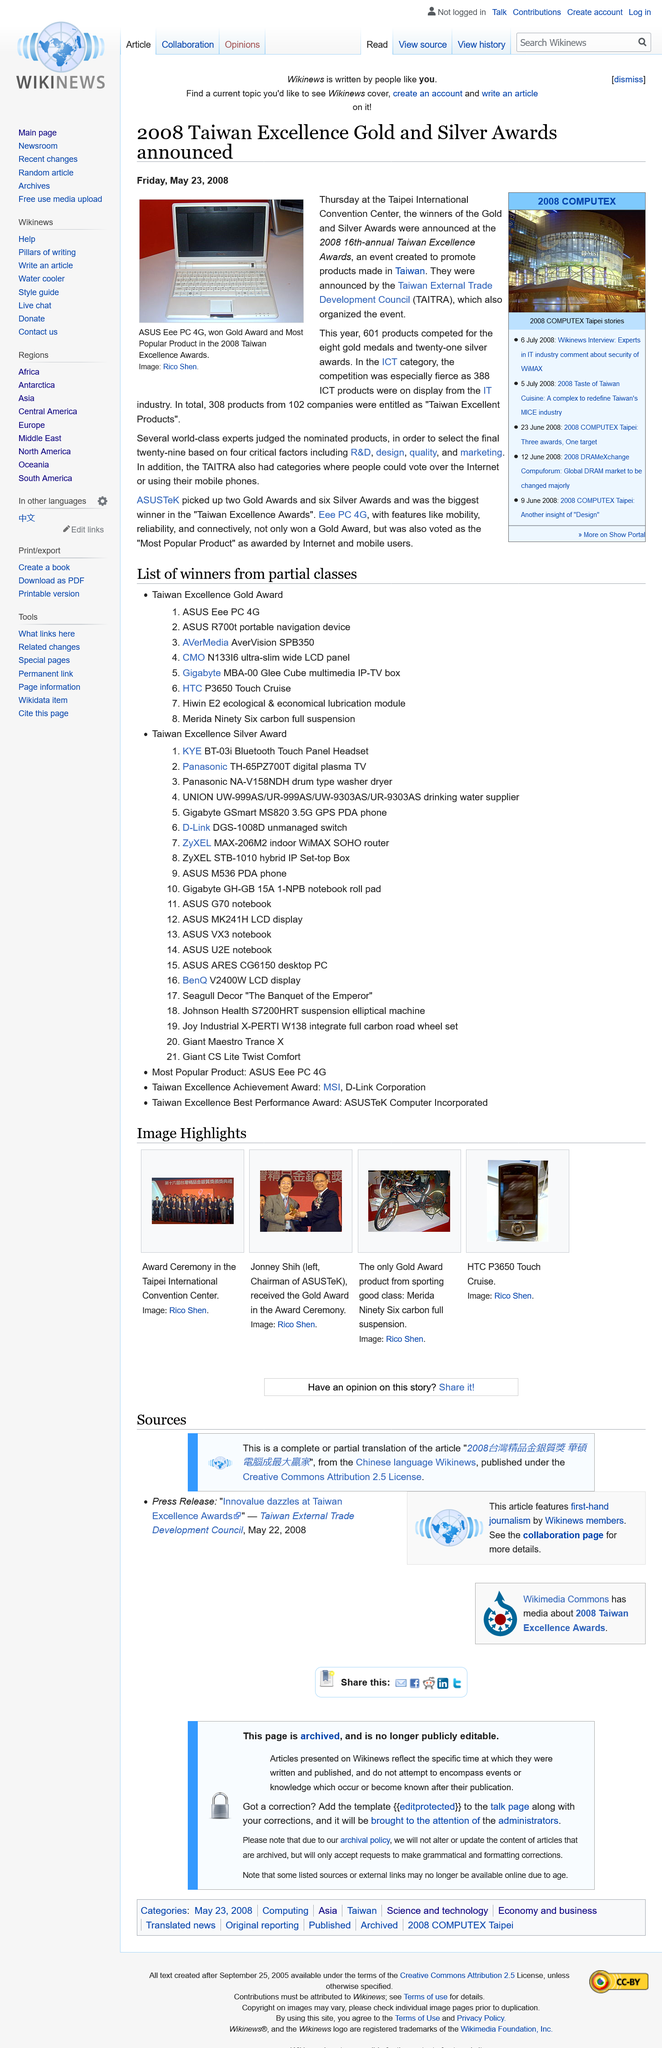List a handful of essential elements in this visual. The Taiwan Excellence Awards in 2008 was held at the Taipei Convention Center. In the ICT category of the Taiwan Excellence Awards, a total of 388 products competed. The Taiwan External Trade Development Council (TAITRA) organizes the Taiwan Excellence Awards. 